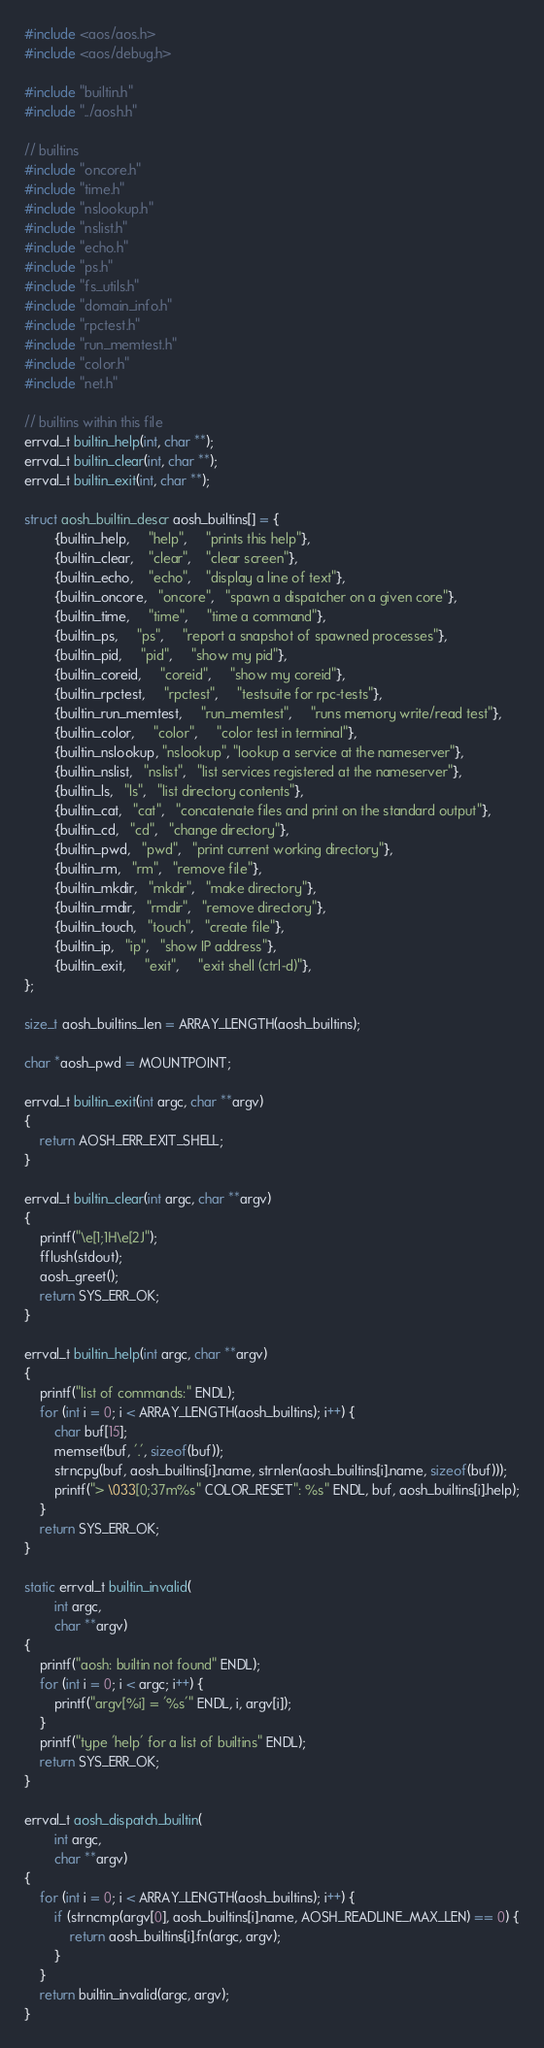<code> <loc_0><loc_0><loc_500><loc_500><_C_>#include <aos/aos.h>
#include <aos/debug.h>

#include "builtin.h"
#include "../aosh.h"

// builtins
#include "oncore.h"
#include "time.h"
#include "nslookup.h"
#include "nslist.h"
#include "echo.h"
#include "ps.h"
#include "fs_utils.h"
#include "domain_info.h"
#include "rpctest.h"
#include "run_memtest.h"
#include "color.h"
#include "net.h"

// builtins within this file
errval_t builtin_help(int, char **);
errval_t builtin_clear(int, char **);
errval_t builtin_exit(int, char **);

struct aosh_builtin_descr aosh_builtins[] = {
        {builtin_help,     "help",     "prints this help"},
        {builtin_clear,    "clear",    "clear screen"},
        {builtin_echo,    "echo",    "display a line of text"},
        {builtin_oncore,   "oncore",   "spawn a dispatcher on a given core"},
        {builtin_time,     "time",     "time a command"},
        {builtin_ps,     "ps",     "report a snapshot of spawned processes"},
        {builtin_pid,     "pid",     "show my pid"},
        {builtin_coreid,     "coreid",     "show my coreid"},
        {builtin_rpctest,     "rpctest",     "testsuite for rpc-tests"},
        {builtin_run_memtest,     "run_memtest",     "runs memory write/read test"},
        {builtin_color,     "color",     "color test in terminal"},
        {builtin_nslookup, "nslookup", "lookup a service at the nameserver"},
        {builtin_nslist,   "nslist",   "list services registered at the nameserver"},
        {builtin_ls,   "ls",   "list directory contents"},
        {builtin_cat,   "cat",   "concatenate files and print on the standard output"},
        {builtin_cd,   "cd",   "change directory"},
        {builtin_pwd,   "pwd",   "print current working directory"},
        {builtin_rm,   "rm",   "remove file"},
        {builtin_mkdir,   "mkdir",   "make directory"},
        {builtin_rmdir,   "rmdir",   "remove directory"},
        {builtin_touch,   "touch",   "create file"},
        {builtin_ip,   "ip",   "show IP address"},
        {builtin_exit,     "exit",     "exit shell (ctrl-d)"},
};

size_t aosh_builtins_len = ARRAY_LENGTH(aosh_builtins);

char *aosh_pwd = MOUNTPOINT;

errval_t builtin_exit(int argc, char **argv)
{
    return AOSH_ERR_EXIT_SHELL;
}

errval_t builtin_clear(int argc, char **argv)
{
    printf("\e[1;1H\e[2J");
    fflush(stdout);
    aosh_greet();
    return SYS_ERR_OK;
}

errval_t builtin_help(int argc, char **argv)
{
    printf("list of commands:" ENDL);
    for (int i = 0; i < ARRAY_LENGTH(aosh_builtins); i++) {
        char buf[15];
        memset(buf, '.', sizeof(buf));
        strncpy(buf, aosh_builtins[i].name, strnlen(aosh_builtins[i].name, sizeof(buf)));
        printf("> \033[0;37m%s" COLOR_RESET": %s" ENDL, buf, aosh_builtins[i].help);
    }
    return SYS_ERR_OK;
}

static errval_t builtin_invalid(
        int argc,
        char **argv)
{
    printf("aosh: builtin not found" ENDL);
    for (int i = 0; i < argc; i++) {
        printf("argv[%i] = '%s'" ENDL, i, argv[i]);
    }
    printf("type 'help' for a list of builtins" ENDL);
    return SYS_ERR_OK;
}

errval_t aosh_dispatch_builtin(
        int argc,
        char **argv)
{
    for (int i = 0; i < ARRAY_LENGTH(aosh_builtins); i++) {
        if (strncmp(argv[0], aosh_builtins[i].name, AOSH_READLINE_MAX_LEN) == 0) {
            return aosh_builtins[i].fn(argc, argv);
        }
    }
    return builtin_invalid(argc, argv);
}
</code> 